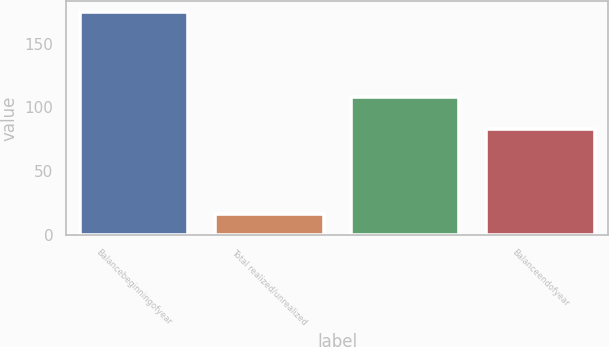Convert chart to OTSL. <chart><loc_0><loc_0><loc_500><loc_500><bar_chart><fcel>Balancebeginningofyear<fcel>Total realized/unrealized<fcel>Unnamed: 2<fcel>Balanceendofyear<nl><fcel>175<fcel>16<fcel>108<fcel>83<nl></chart> 